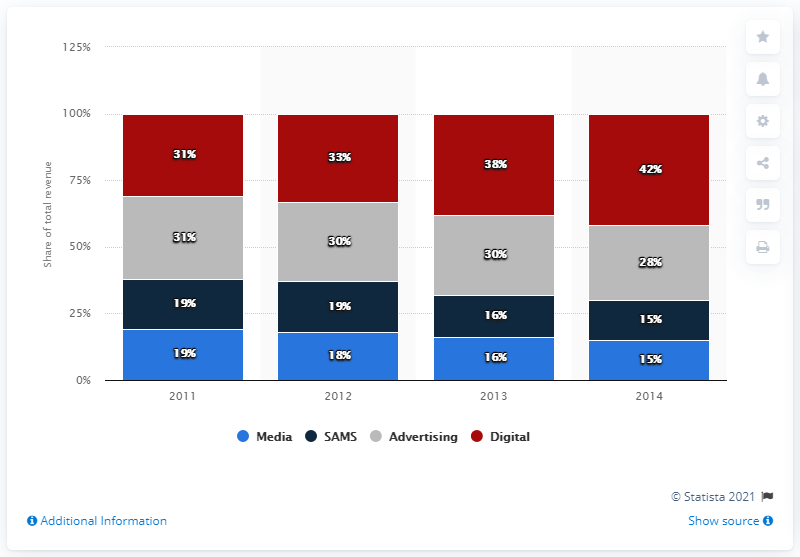Highlight a few significant elements in this photo. The ratio of the shortest light blue bar to the shortest navy blue bar in group A is 1 to 1. In 2012, the percentage share of media in total revenue was 18%. 